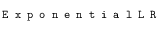Convert formula to latex. <formula><loc_0><loc_0><loc_500><loc_500>E x p o n e n t i a l L R</formula> 